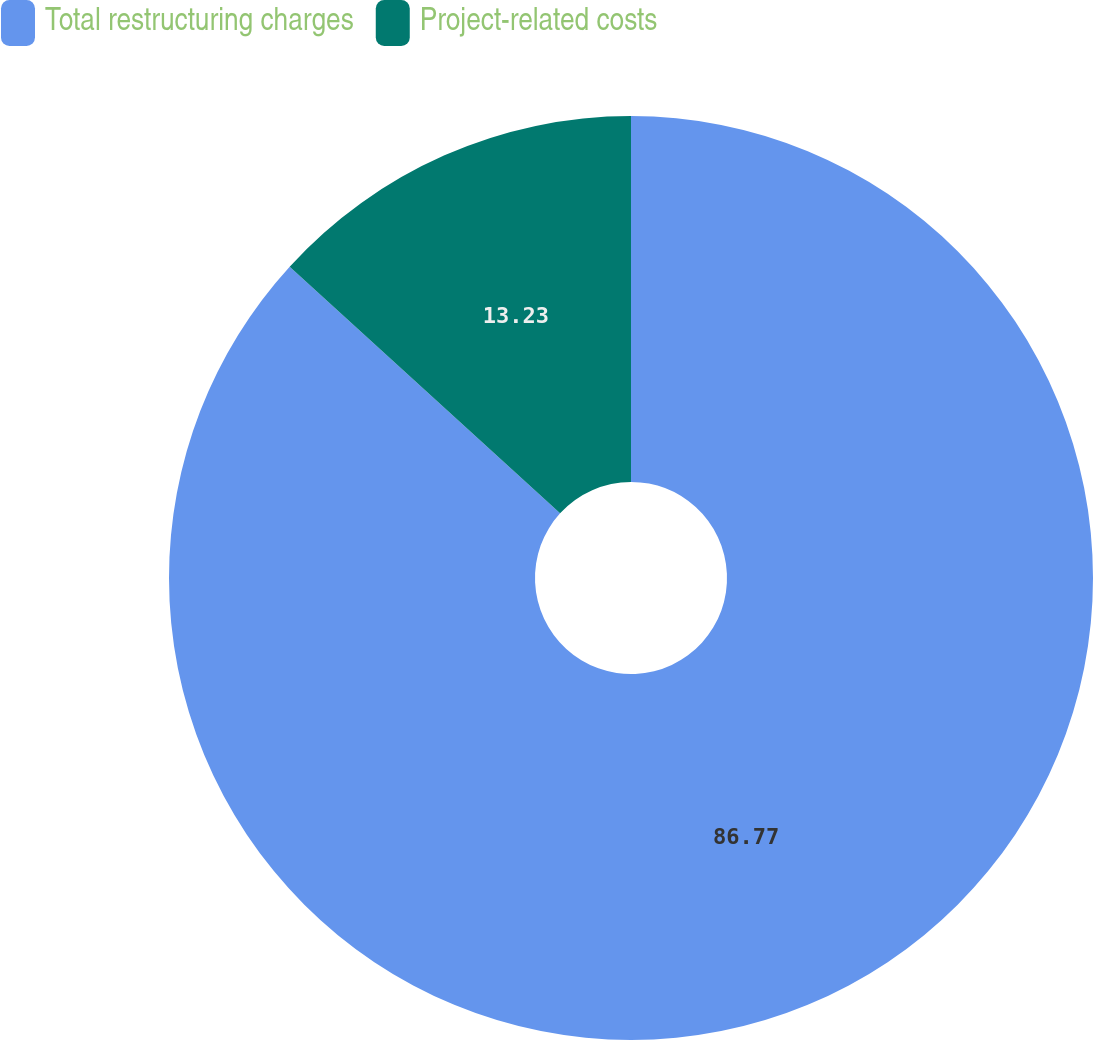<chart> <loc_0><loc_0><loc_500><loc_500><pie_chart><fcel>Total restructuring charges<fcel>Project-related costs<nl><fcel>86.77%<fcel>13.23%<nl></chart> 